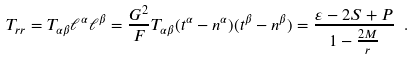<formula> <loc_0><loc_0><loc_500><loc_500>T _ { r r } = T _ { \alpha \beta } \ell ^ { \alpha } \ell ^ { \beta } = \frac { G ^ { 2 } } F T _ { \alpha \beta } ( t ^ { \alpha } - n ^ { \alpha } ) ( t ^ { \beta } - n ^ { \beta } ) = \frac { \varepsilon - 2 S + P } { 1 - \frac { 2 M } r } \ .</formula> 